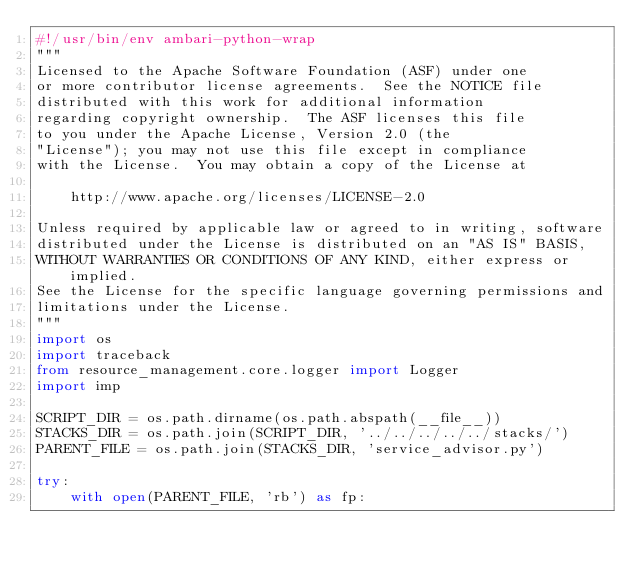<code> <loc_0><loc_0><loc_500><loc_500><_Python_>#!/usr/bin/env ambari-python-wrap
"""
Licensed to the Apache Software Foundation (ASF) under one
or more contributor license agreements.  See the NOTICE file
distributed with this work for additional information
regarding copyright ownership.  The ASF licenses this file
to you under the Apache License, Version 2.0 (the
"License"); you may not use this file except in compliance
with the License.  You may obtain a copy of the License at

    http://www.apache.org/licenses/LICENSE-2.0

Unless required by applicable law or agreed to in writing, software
distributed under the License is distributed on an "AS IS" BASIS,
WITHOUT WARRANTIES OR CONDITIONS OF ANY KIND, either express or implied.
See the License for the specific language governing permissions and
limitations under the License.
"""
import os
import traceback
from resource_management.core.logger import Logger
import imp

SCRIPT_DIR = os.path.dirname(os.path.abspath(__file__))
STACKS_DIR = os.path.join(SCRIPT_DIR, '../../../../../stacks/')
PARENT_FILE = os.path.join(STACKS_DIR, 'service_advisor.py')

try:
    with open(PARENT_FILE, 'rb') as fp:</code> 